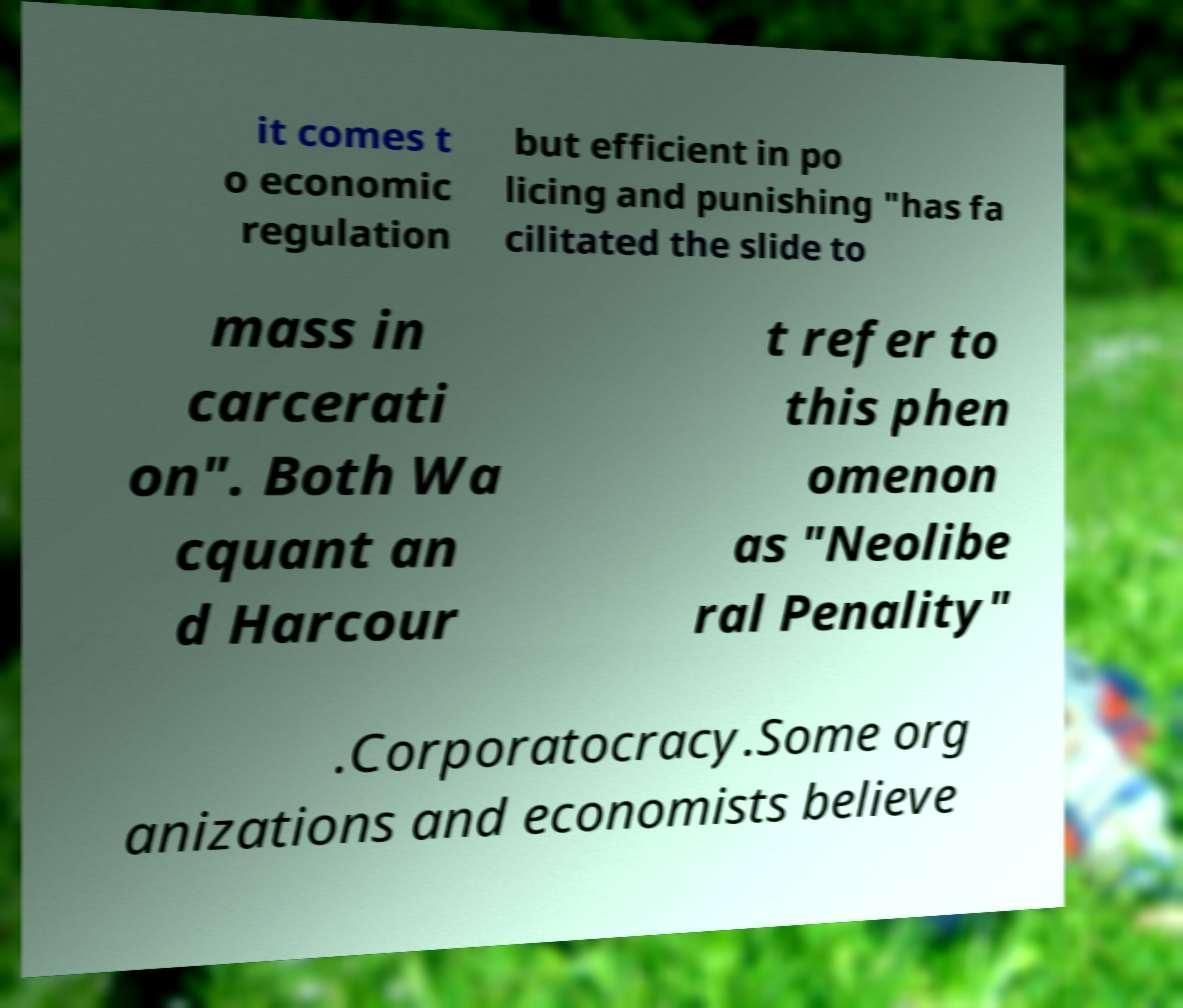I need the written content from this picture converted into text. Can you do that? it comes t o economic regulation but efficient in po licing and punishing "has fa cilitated the slide to mass in carcerati on". Both Wa cquant an d Harcour t refer to this phen omenon as "Neolibe ral Penality" .Corporatocracy.Some org anizations and economists believe 